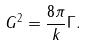<formula> <loc_0><loc_0><loc_500><loc_500>G ^ { 2 } = \frac { 8 \pi } { k } \Gamma .</formula> 